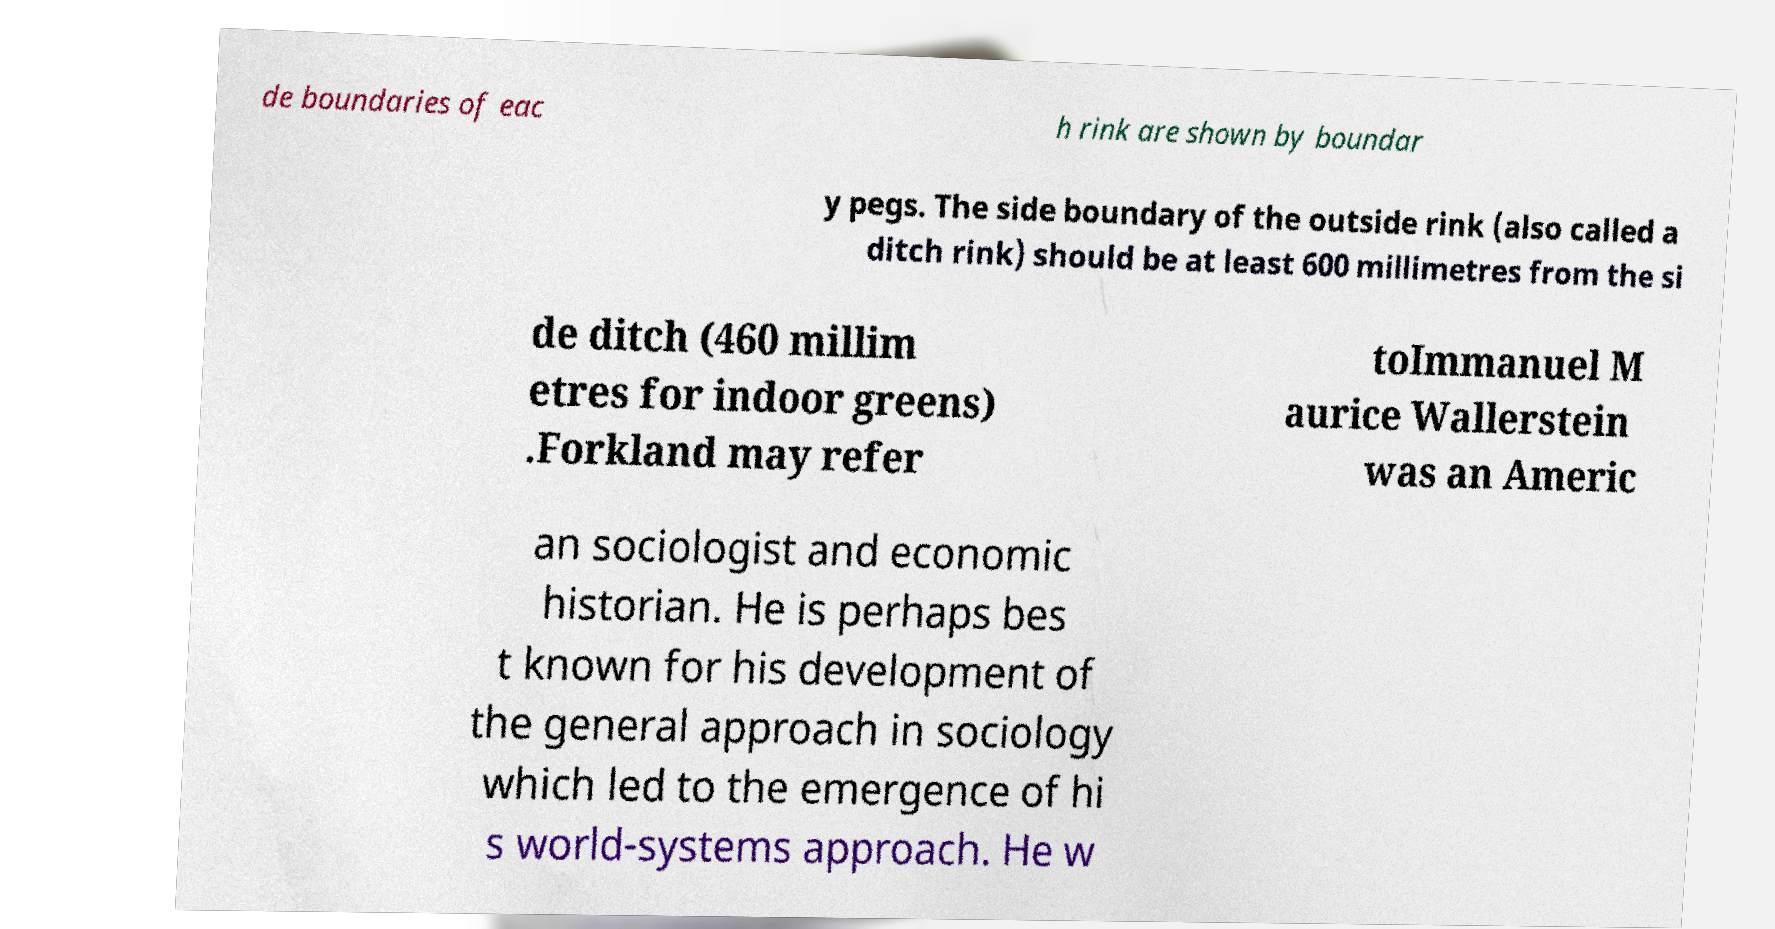Please read and relay the text visible in this image. What does it say? de boundaries of eac h rink are shown by boundar y pegs. The side boundary of the outside rink (also called a ditch rink) should be at least 600 millimetres from the si de ditch (460 millim etres for indoor greens) .Forkland may refer toImmanuel M aurice Wallerstein was an Americ an sociologist and economic historian. He is perhaps bes t known for his development of the general approach in sociology which led to the emergence of hi s world-systems approach. He w 